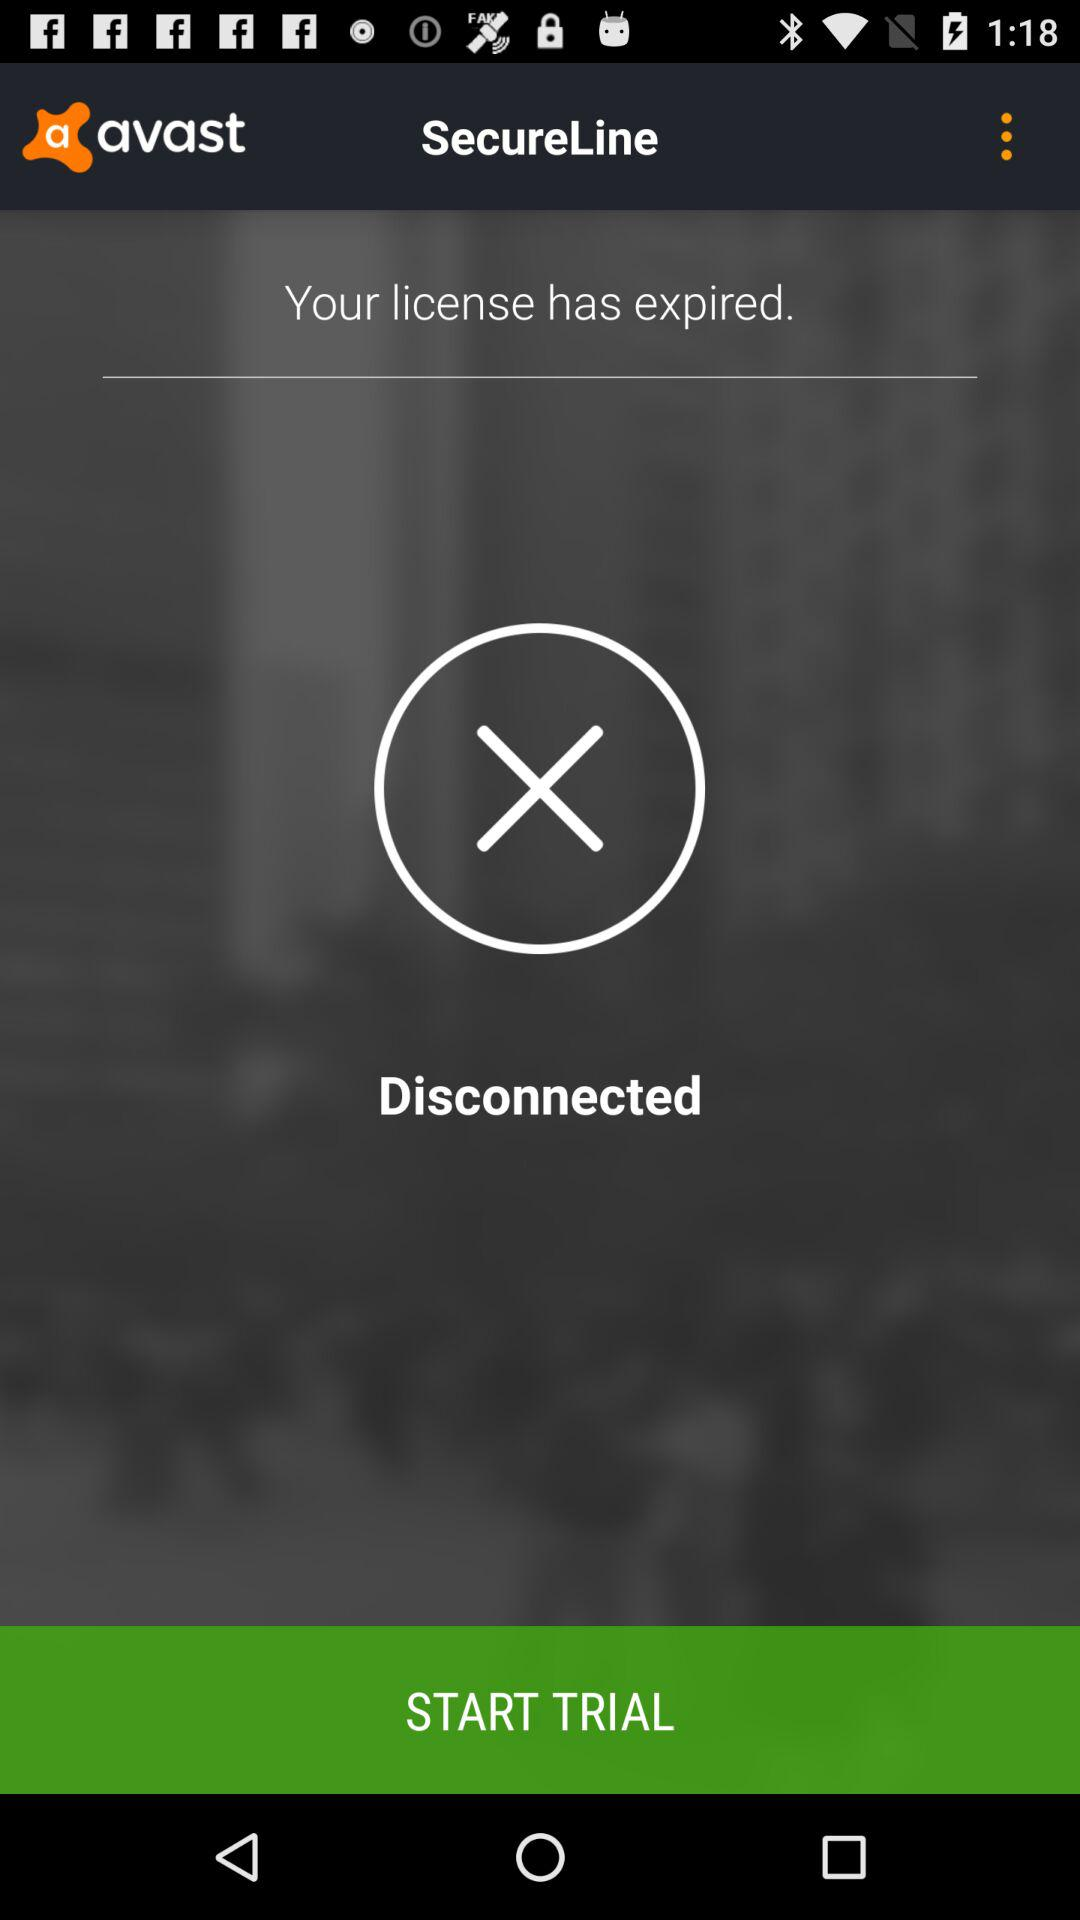What's the status of my "avast" license? Your "avast" license has expired. 